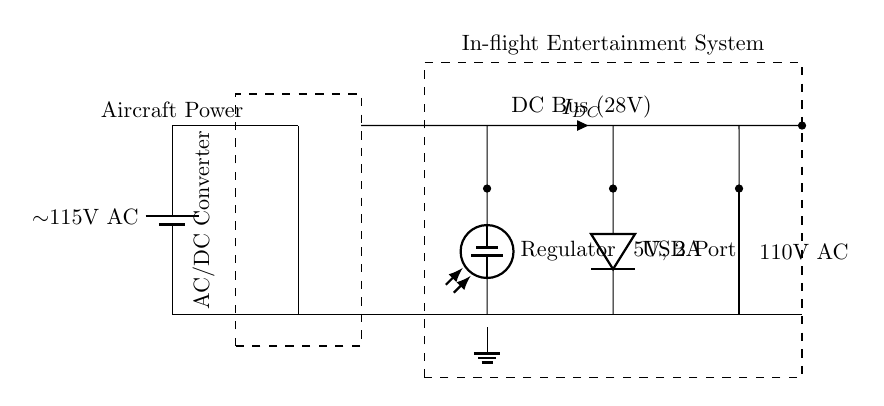What is the voltage of the DC Bus? The DC Bus is labeled with 28V, which indicates the voltage level provided in this part of the circuit.
Answer: 28V What type of power does the USB Port supply? The USB Port is marked with 5V, indicating the type of power output calculated for USB charging applications, also specifically noted as 2A current.
Answer: 5V, 2A What component converts AC to DC in this circuit? The AC/DC Converter is shown between the AC source and the DC Bus, responsible for converting alternating current to direct current.
Answer: AC/DC Converter What is the function of the voltage regulator in this circuit? The voltage regulator is used to maintain a consistent output voltage, ensuring that any variations in the input voltage don't affect the power supply to the connected devices.
Answer: Maintain output voltage How many power outputs are shown in this circuit? There are two distinct power outputs shown: one USB Port and one Seat Power Outlet, indicating different options for passengers or systems to charge or receive power.
Answer: Two Which component is responsible for providing 110V AC? The Seat Power Outlet is labeled with 110V AC, serving as the outlet for this voltage type designated for passenger use or other equipment.
Answer: Seat Power Outlet What is the current designation in the DC Bus? The DC Bus has an indication of a current label represented as I DC, suggesting that it is the DC current flowing through the circuit.
Answer: I DC 